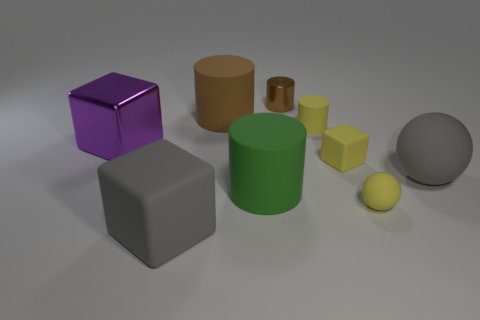There is a cylinder that is the same color as the small block; what is its size?
Your answer should be very brief. Small. What number of blocks are big green objects or matte things?
Keep it short and to the point. 2. There is a rubber thing that is behind the tiny yellow rubber cylinder; is it the same shape as the big gray object left of the yellow cube?
Your response must be concise. No. What material is the small cube?
Make the answer very short. Rubber. The matte object that is the same color as the big matte sphere is what shape?
Offer a terse response. Cube. What number of gray rubber blocks are the same size as the purple block?
Provide a succinct answer. 1. What number of things are either matte things that are in front of the yellow sphere or big matte things that are behind the large metal block?
Make the answer very short. 2. Does the brown cylinder to the left of the shiny cylinder have the same material as the cylinder in front of the big metallic block?
Your answer should be compact. Yes. The shiny thing behind the large cylinder behind the green rubber thing is what shape?
Offer a terse response. Cylinder. Is there anything else that is the same color as the big shiny object?
Your answer should be compact. No. 